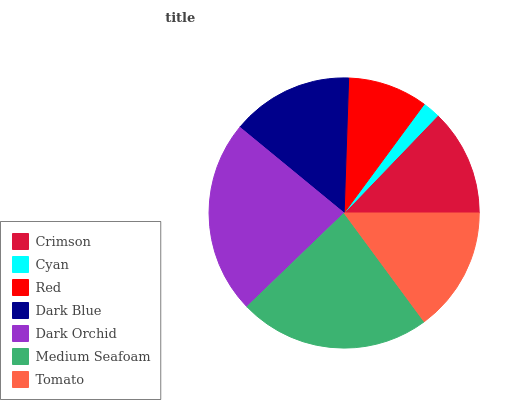Is Cyan the minimum?
Answer yes or no. Yes. Is Dark Orchid the maximum?
Answer yes or no. Yes. Is Red the minimum?
Answer yes or no. No. Is Red the maximum?
Answer yes or no. No. Is Red greater than Cyan?
Answer yes or no. Yes. Is Cyan less than Red?
Answer yes or no. Yes. Is Cyan greater than Red?
Answer yes or no. No. Is Red less than Cyan?
Answer yes or no. No. Is Dark Blue the high median?
Answer yes or no. Yes. Is Dark Blue the low median?
Answer yes or no. Yes. Is Red the high median?
Answer yes or no. No. Is Dark Orchid the low median?
Answer yes or no. No. 